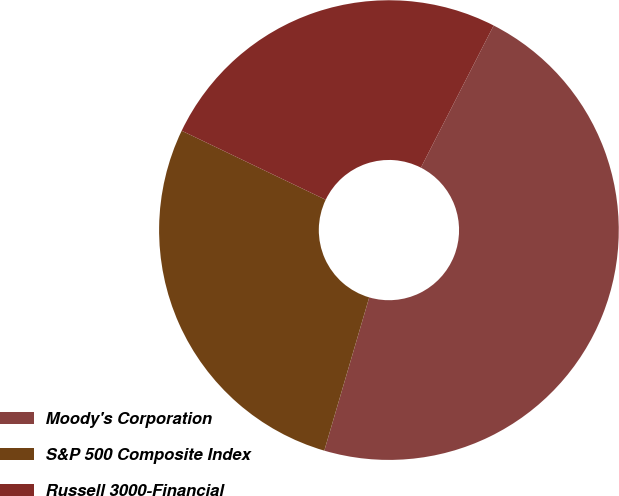Convert chart. <chart><loc_0><loc_0><loc_500><loc_500><pie_chart><fcel>Moody's Corporation<fcel>S&P 500 Composite Index<fcel>Russell 3000-Financial<nl><fcel>47.01%<fcel>27.58%<fcel>25.42%<nl></chart> 